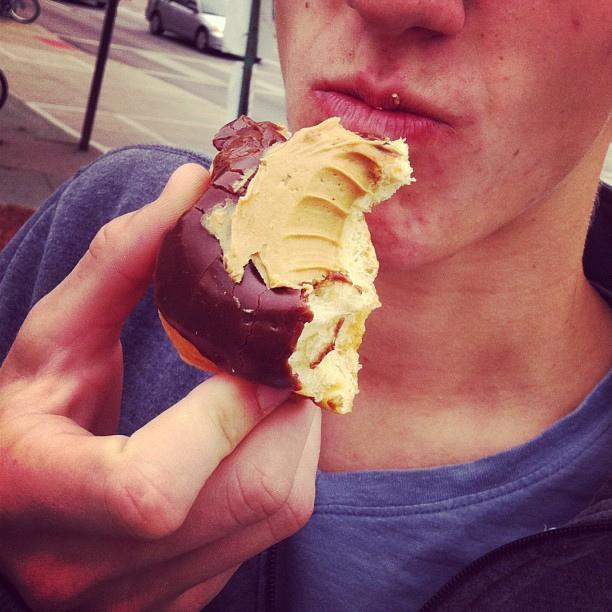How many wheels are in the shot?
Give a very brief answer. 3. 